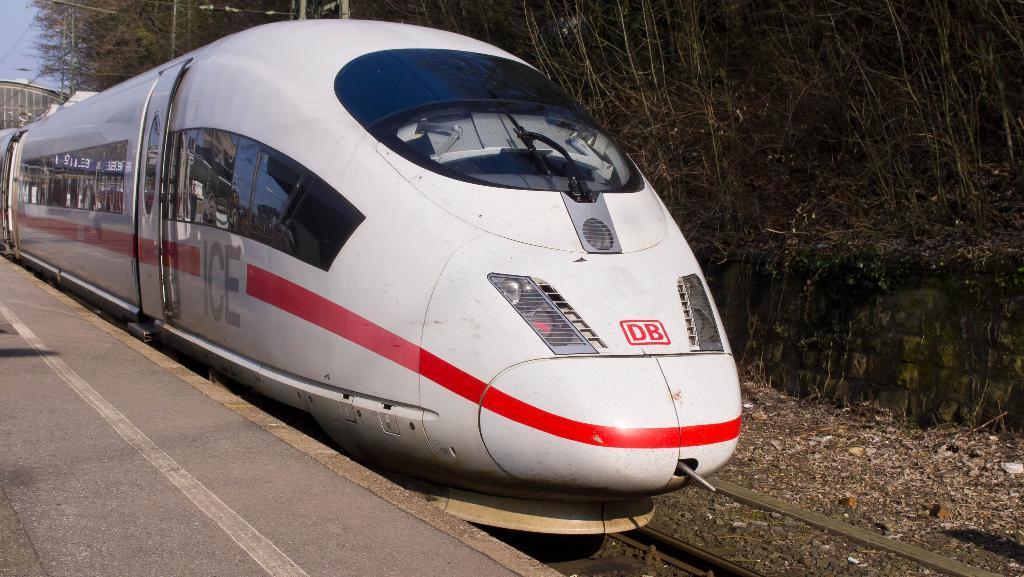Could you give a brief overview of what you see in this image? In the image in the center, we can see one train, which is in white color. In the background, we can see the sky, trees and railway track. 